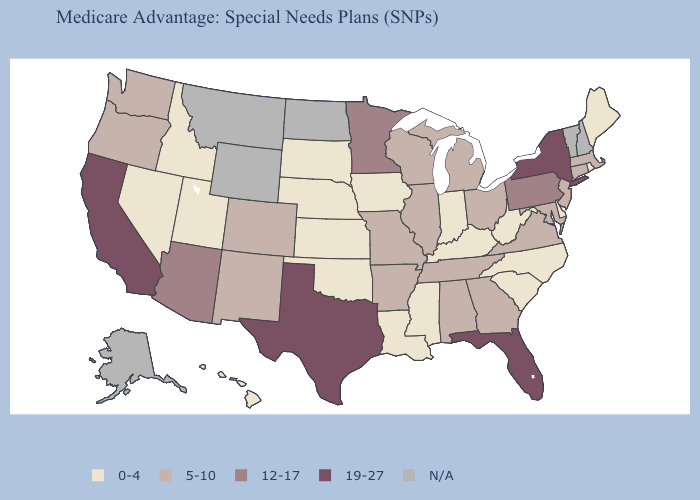Name the states that have a value in the range 19-27?
Be succinct. California, Florida, New York, Texas. What is the lowest value in the South?
Concise answer only. 0-4. What is the value of South Dakota?
Be succinct. 0-4. Which states hav the highest value in the West?
Give a very brief answer. California. What is the lowest value in the Northeast?
Write a very short answer. 0-4. Name the states that have a value in the range 12-17?
Be succinct. Arizona, Minnesota, Pennsylvania. What is the value of Minnesota?
Concise answer only. 12-17. Name the states that have a value in the range 5-10?
Short answer required. Alabama, Arkansas, Colorado, Connecticut, Georgia, Illinois, Massachusetts, Maryland, Michigan, Missouri, New Jersey, New Mexico, Ohio, Oregon, Tennessee, Virginia, Washington, Wisconsin. What is the value of South Dakota?
Keep it brief. 0-4. Name the states that have a value in the range 5-10?
Answer briefly. Alabama, Arkansas, Colorado, Connecticut, Georgia, Illinois, Massachusetts, Maryland, Michigan, Missouri, New Jersey, New Mexico, Ohio, Oregon, Tennessee, Virginia, Washington, Wisconsin. What is the value of Alabama?
Be succinct. 5-10. How many symbols are there in the legend?
Answer briefly. 5. Does California have the highest value in the West?
Quick response, please. Yes. Which states have the lowest value in the USA?
Answer briefly. Delaware, Hawaii, Iowa, Idaho, Indiana, Kansas, Kentucky, Louisiana, Maine, Mississippi, North Carolina, Nebraska, Nevada, Oklahoma, Rhode Island, South Carolina, South Dakota, Utah, West Virginia. What is the value of Montana?
Keep it brief. N/A. 